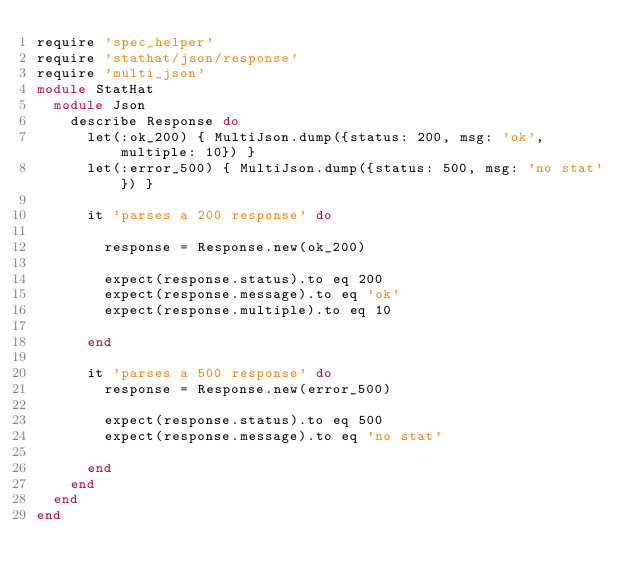<code> <loc_0><loc_0><loc_500><loc_500><_Ruby_>require 'spec_helper'
require 'stathat/json/response'
require 'multi_json'
module StatHat
  module Json
    describe Response do
      let(:ok_200) { MultiJson.dump({status: 200, msg: 'ok', multiple: 10}) }
      let(:error_500) { MultiJson.dump({status: 500, msg: 'no stat'}) }

      it 'parses a 200 response' do

        response = Response.new(ok_200)

        expect(response.status).to eq 200
        expect(response.message).to eq 'ok'
        expect(response.multiple).to eq 10

      end

      it 'parses a 500 response' do
        response = Response.new(error_500)

        expect(response.status).to eq 500
        expect(response.message).to eq 'no stat'

      end
    end
  end
end</code> 